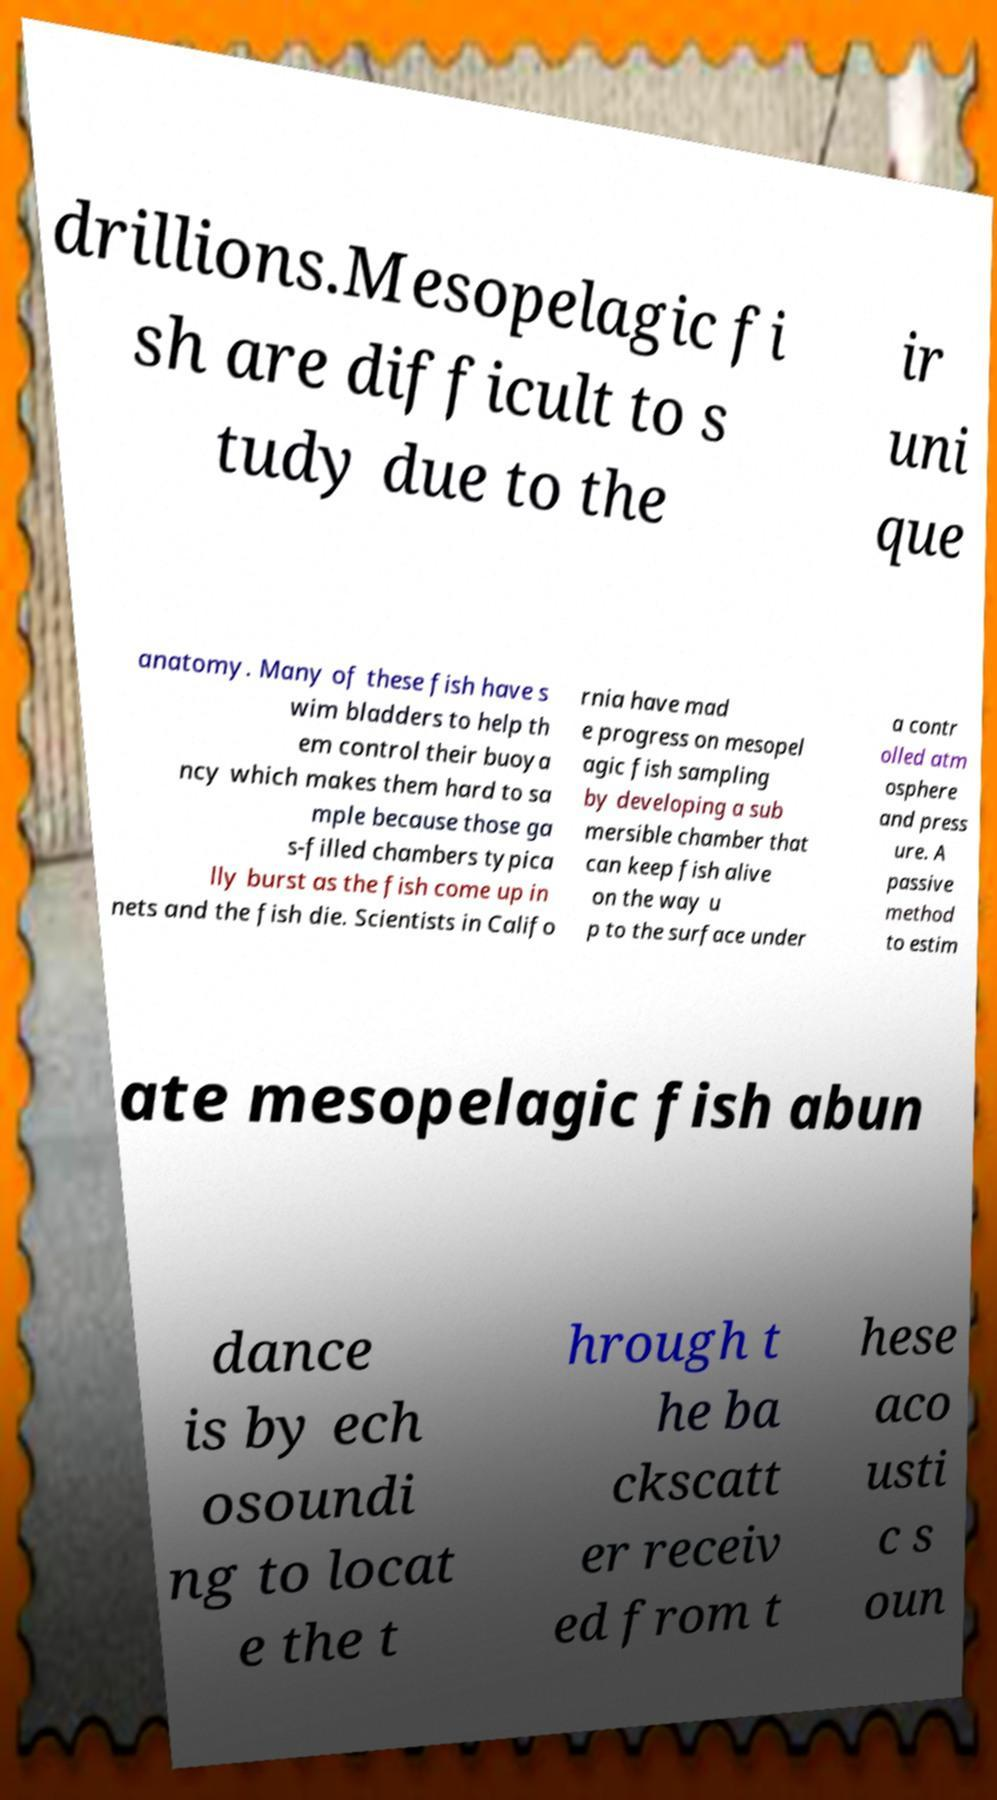What messages or text are displayed in this image? I need them in a readable, typed format. drillions.Mesopelagic fi sh are difficult to s tudy due to the ir uni que anatomy. Many of these fish have s wim bladders to help th em control their buoya ncy which makes them hard to sa mple because those ga s-filled chambers typica lly burst as the fish come up in nets and the fish die. Scientists in Califo rnia have mad e progress on mesopel agic fish sampling by developing a sub mersible chamber that can keep fish alive on the way u p to the surface under a contr olled atm osphere and press ure. A passive method to estim ate mesopelagic fish abun dance is by ech osoundi ng to locat e the t hrough t he ba ckscatt er receiv ed from t hese aco usti c s oun 